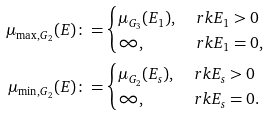Convert formula to latex. <formula><loc_0><loc_0><loc_500><loc_500>\mu _ { \max , G _ { 2 } } ( E ) \colon = & \begin{cases} \mu _ { G _ { 3 } } ( E _ { 1 } ) , & \ r k E _ { 1 } > 0 \\ \infty , & \ r k E _ { 1 } = 0 , \end{cases} \\ \mu _ { \min , G _ { 2 } } ( E ) \colon = & \begin{cases} \mu _ { G _ { 2 } } ( E _ { s } ) , & \ r k E _ { s } > 0 \\ \infty , & \ r k E _ { s } = 0 . \end{cases}</formula> 